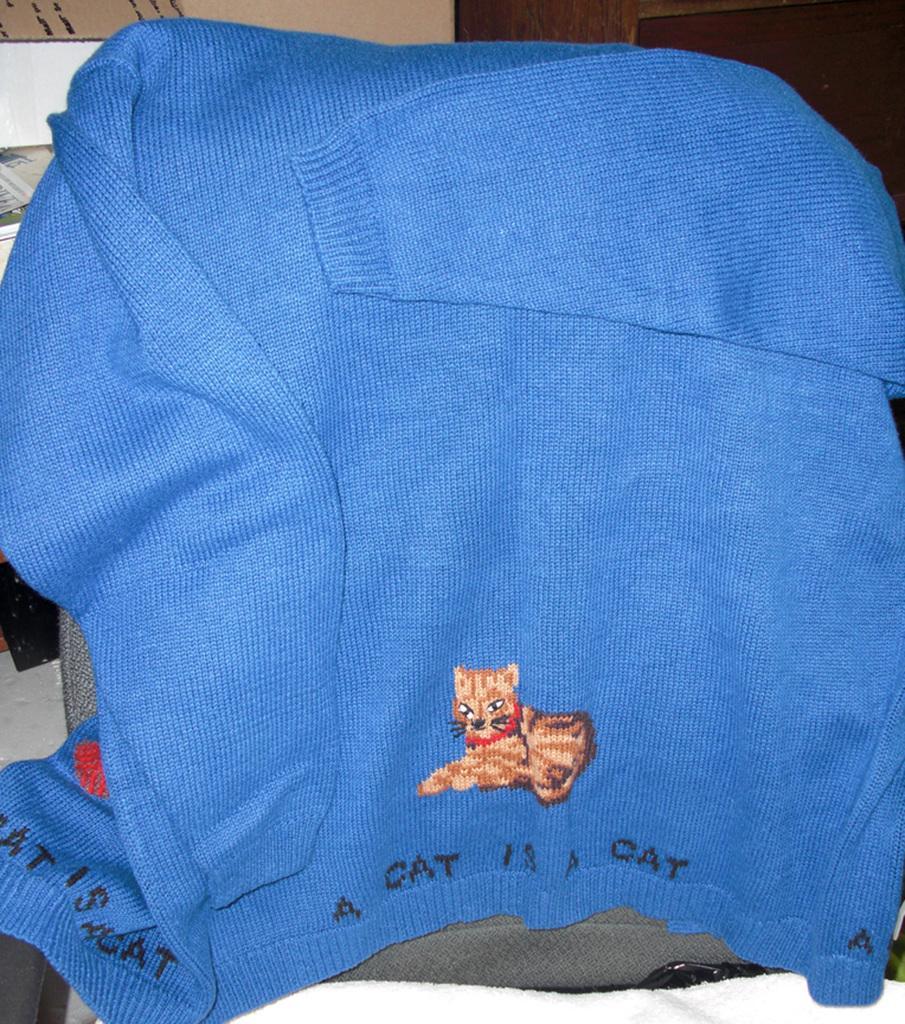What type of clothing item is in the image? There is a blue sweatshirt in the image. What is the sweatshirt placed on? The sweatshirt is on clothes. What can be seen in the background of the image? There is a table and a cupboard in the background of the image. What type of cream is being used by the group in the image? There is no group or cream present in the image; it only features a blue sweatshirt on clothes with a table and cupboard in the background. 